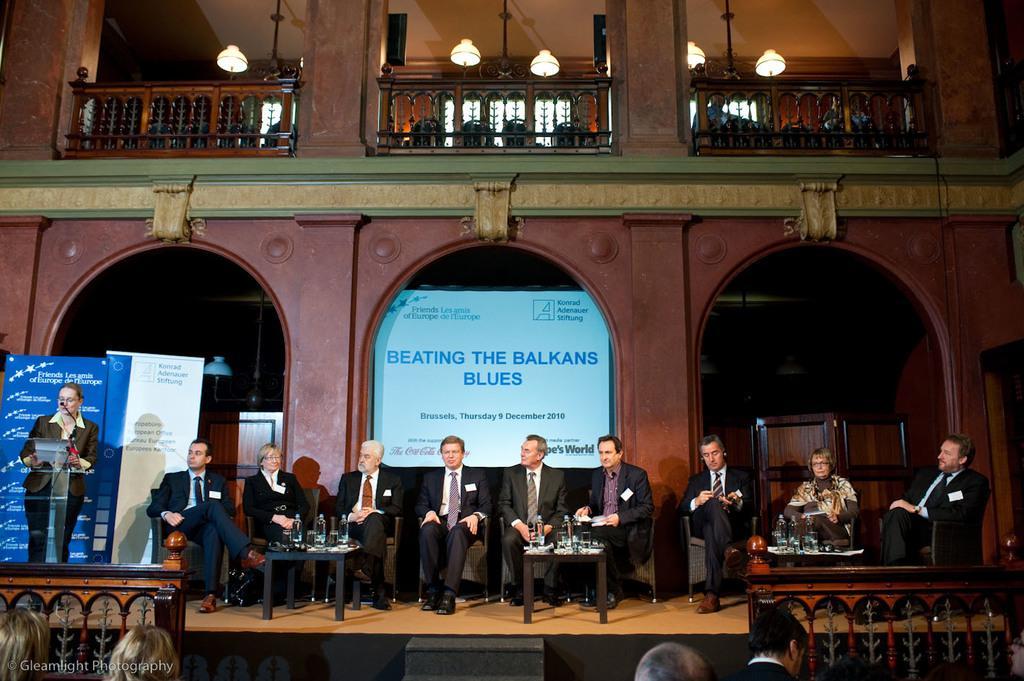How would you summarize this image in a sentence or two? In the center of the image some persons are sitting on a chair, in-front of them there is a table. On the table we can see bottles are present. On the left side of the image a lady is standing in-front of podium and mic is there. In the background of the image we can see wall, board, lights, grill are there. At the bottom of the image some persons are there. At the top of the image roof is there. 